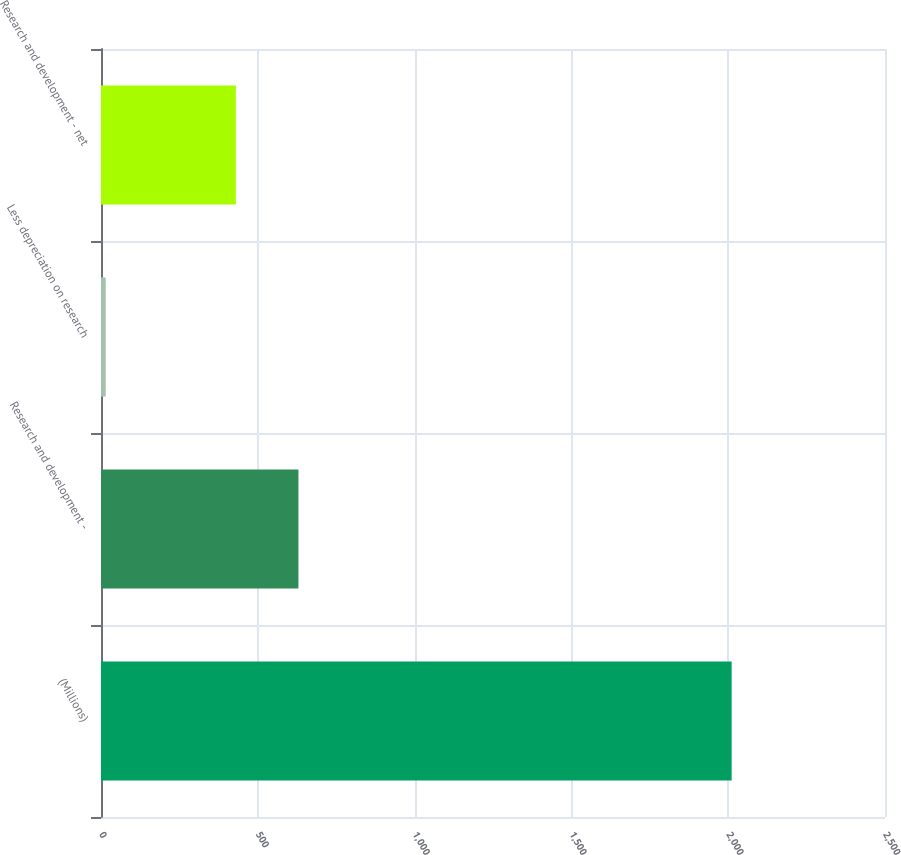Convert chart. <chart><loc_0><loc_0><loc_500><loc_500><bar_chart><fcel>(Millions)<fcel>Research and development -<fcel>Less depreciation on research<fcel>Research and development - net<nl><fcel>2011<fcel>629.6<fcel>15<fcel>430<nl></chart> 